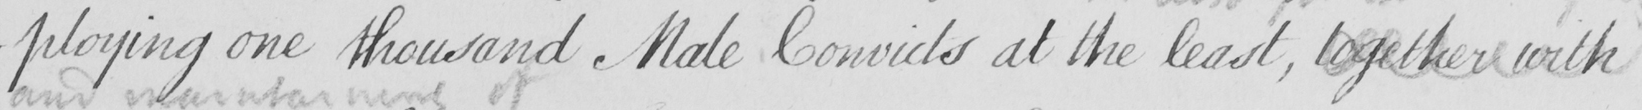Please provide the text content of this handwritten line. -ploying one thousand Male Convicts at the least , together with 